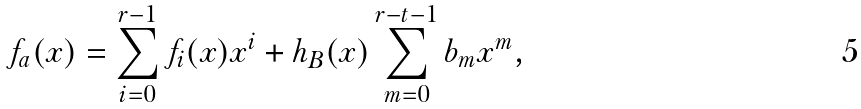Convert formula to latex. <formula><loc_0><loc_0><loc_500><loc_500>f _ { a } ( x ) = \sum _ { i = 0 } ^ { r - 1 } f _ { i } ( x ) x ^ { i } + h _ { B } ( x ) \sum _ { m = 0 } ^ { r - t - 1 } b _ { m } x ^ { m } ,</formula> 